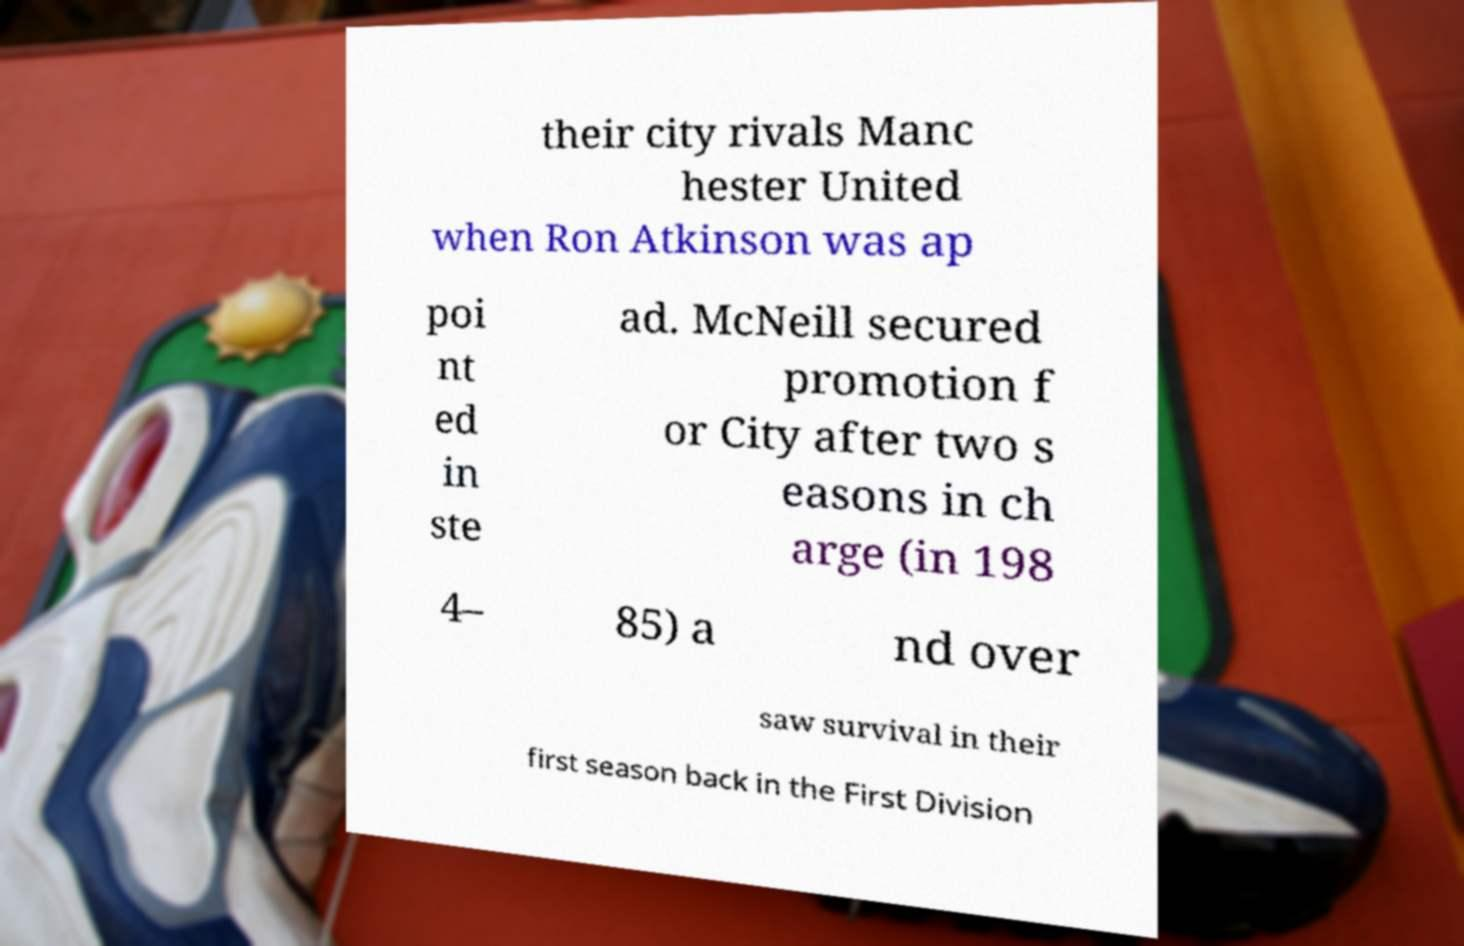Could you extract and type out the text from this image? their city rivals Manc hester United when Ron Atkinson was ap poi nt ed in ste ad. McNeill secured promotion f or City after two s easons in ch arge (in 198 4– 85) a nd over saw survival in their first season back in the First Division 